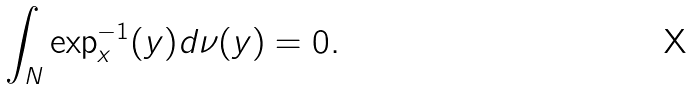Convert formula to latex. <formula><loc_0><loc_0><loc_500><loc_500>\int _ { N } \exp _ { x } ^ { - 1 } ( y ) d \nu ( y ) = 0 .</formula> 